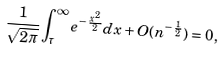Convert formula to latex. <formula><loc_0><loc_0><loc_500><loc_500>\frac { 1 } { \sqrt { 2 \pi } } \int _ { \tau } ^ { \infty } e ^ { - \frac { x ^ { 2 } } { 2 } } d x + O ( n ^ { - \frac { 1 } { 2 } } ) = 0 ,</formula> 